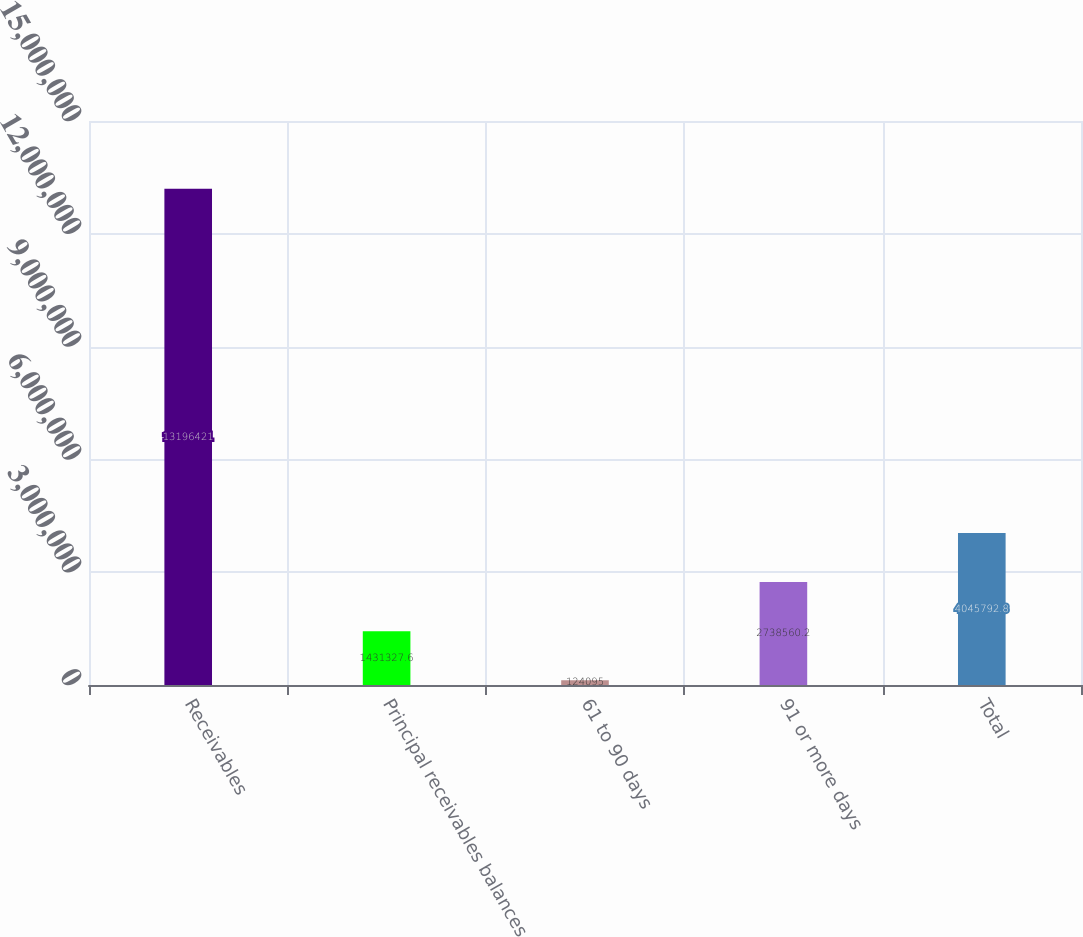Convert chart to OTSL. <chart><loc_0><loc_0><loc_500><loc_500><bar_chart><fcel>Receivables<fcel>Principal receivables balances<fcel>61 to 90 days<fcel>91 or more days<fcel>Total<nl><fcel>1.31964e+07<fcel>1.43133e+06<fcel>124095<fcel>2.73856e+06<fcel>4.04579e+06<nl></chart> 